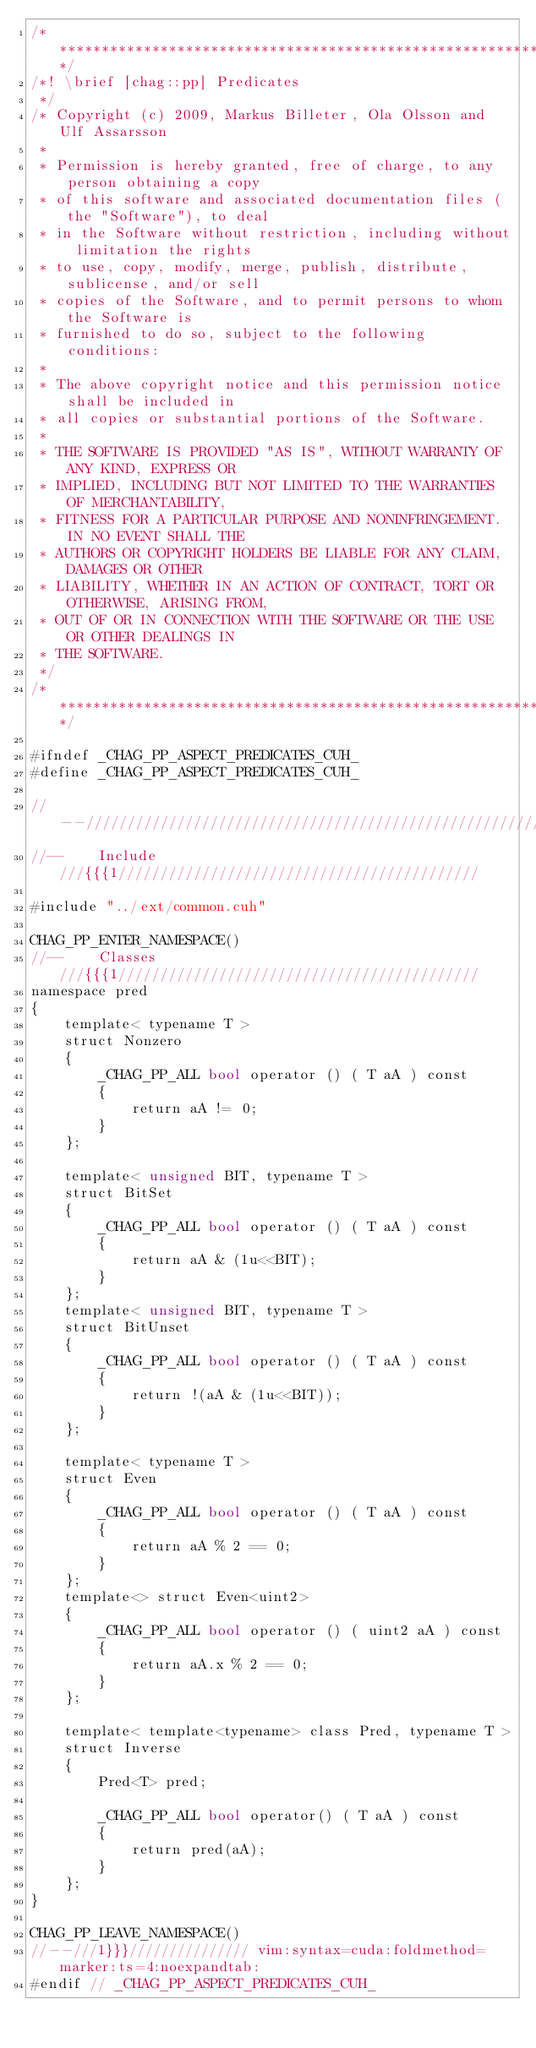<code> <loc_0><loc_0><loc_500><loc_500><_Cuda_>/****************************************************************************/
/*!	\brief [chag::pp] Predicates
 */
/* Copyright (c) 2009, Markus Billeter, Ola Olsson and Ulf Assarsson
 * 
 * Permission is hereby granted, free of charge, to any person obtaining a copy
 * of this software and associated documentation files (the "Software"), to deal
 * in the Software without restriction, including without limitation the rights
 * to use, copy, modify, merge, publish, distribute, sublicense, and/or sell
 * copies of the Software, and to permit persons to whom the Software is
 * furnished to do so, subject to the following conditions:
 * 
 * The above copyright notice and this permission notice shall be included in
 * all copies or substantial portions of the Software.
 * 
 * THE SOFTWARE IS PROVIDED "AS IS", WITHOUT WARRANTY OF ANY KIND, EXPRESS OR
 * IMPLIED, INCLUDING BUT NOT LIMITED TO THE WARRANTIES OF MERCHANTABILITY,
 * FITNESS FOR A PARTICULAR PURPOSE AND NONINFRINGEMENT. IN NO EVENT SHALL THE
 * AUTHORS OR COPYRIGHT HOLDERS BE LIABLE FOR ANY CLAIM, DAMAGES OR OTHER
 * LIABILITY, WHETHER IN AN ACTION OF CONTRACT, TORT OR OTHERWISE, ARISING FROM,
 * OUT OF OR IN CONNECTION WITH THE SOFTWARE OR THE USE OR OTHER DEALINGS IN
 * THE SOFTWARE.
 */
/****************************************************************************/

#ifndef _CHAG_PP_ASPECT_PREDICATES_CUH_
#define _CHAG_PP_ASPECT_PREDICATES_CUH_

//--//////////////////////////////////////////////////////////////////////////
//--	Include				///{{{1///////////////////////////////////////////

#include "../ext/common.cuh"

CHAG_PP_ENTER_NAMESPACE()
//--	Classes				///{{{1///////////////////////////////////////////
namespace pred
{
	template< typename T >
	struct Nonzero
	{
		_CHAG_PP_ALL bool operator () ( T aA ) const
		{
			return aA != 0;
		}
	};

	template< unsigned BIT, typename T >
	struct BitSet
	{
		_CHAG_PP_ALL bool operator () ( T aA ) const
		{
			return aA & (1u<<BIT);
		}
	};
	template< unsigned BIT, typename T >
	struct BitUnset
	{
		_CHAG_PP_ALL bool operator () ( T aA ) const
		{
			return !(aA & (1u<<BIT));
		}
	};
	
	template< typename T >
	struct Even
	{
		_CHAG_PP_ALL bool operator () ( T aA ) const
		{
			return aA % 2 == 0;
		}
	};
	template<> struct Even<uint2>
	{
		_CHAG_PP_ALL bool operator () ( uint2 aA ) const
		{
			return aA.x % 2 == 0;
		}
	};

	template< template<typename> class Pred, typename T >
	struct Inverse
	{
		Pred<T> pred;

		_CHAG_PP_ALL bool operator() ( T aA ) const
		{
			return pred(aA);
		}
	};
}

CHAG_PP_LEAVE_NAMESPACE()
//--///1}}}/////////////// vim:syntax=cuda:foldmethod=marker:ts=4:noexpandtab: 
#endif // _CHAG_PP_ASPECT_PREDICATES_CUH_
</code> 